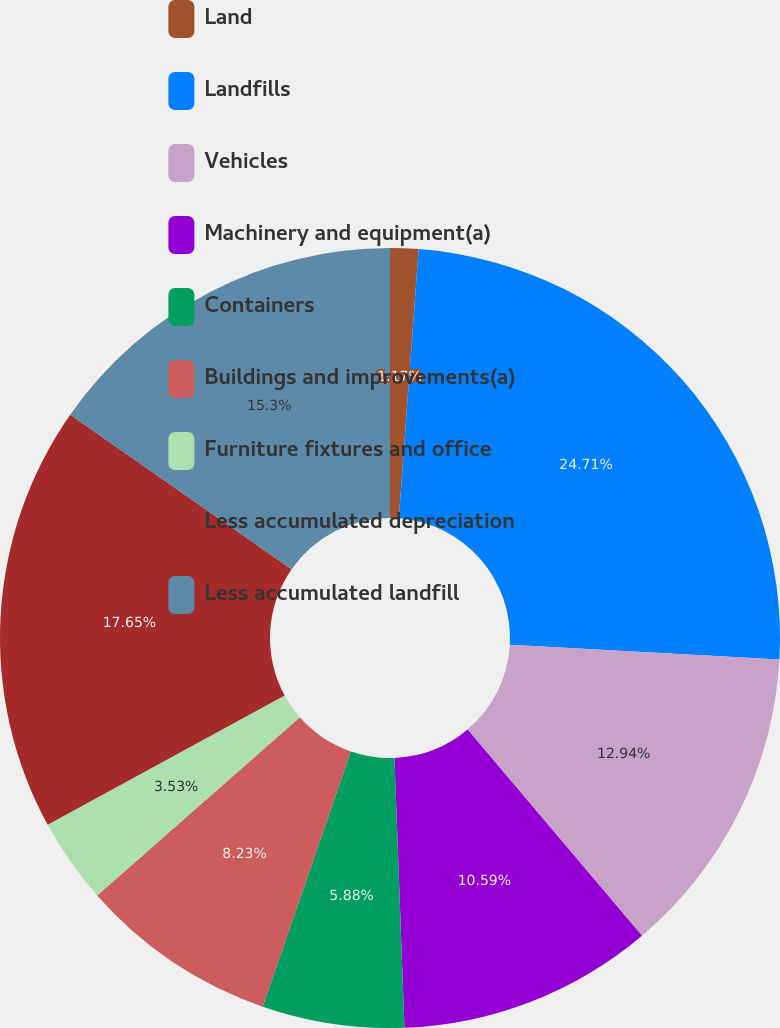<chart> <loc_0><loc_0><loc_500><loc_500><pie_chart><fcel>Land<fcel>Landfills<fcel>Vehicles<fcel>Machinery and equipment(a)<fcel>Containers<fcel>Buildings and improvements(a)<fcel>Furniture fixtures and office<fcel>Less accumulated depreciation<fcel>Less accumulated landfill<nl><fcel>1.17%<fcel>24.71%<fcel>12.94%<fcel>10.59%<fcel>5.88%<fcel>8.23%<fcel>3.53%<fcel>17.65%<fcel>15.3%<nl></chart> 